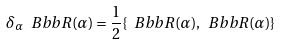<formula> <loc_0><loc_0><loc_500><loc_500>\delta _ { \alpha } { \ B b b R } ( \alpha ) = \frac { 1 } { 2 } \{ { \ B b b R } ( \alpha ) , { \ B b b R } ( \alpha ) \}</formula> 